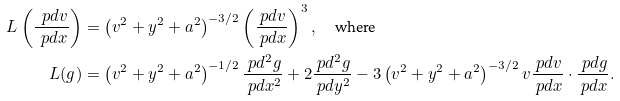<formula> <loc_0><loc_0><loc_500><loc_500>L \left ( \frac { \ p d v } { \ p d x } \right ) & = \left ( v ^ { 2 } + y ^ { 2 } + a ^ { 2 } \right ) ^ { - 3 / 2 } \left ( \frac { \ p d v } { \ p d x } \right ) ^ { 3 } , \quad \text {where} \\ L ( g ) & = \left ( v ^ { 2 } + y ^ { 2 } + a ^ { 2 } \right ) ^ { - 1 / 2 } \frac { \ p d ^ { 2 } g } { \ p d x ^ { 2 } } + 2 \frac { \ p d ^ { 2 } g } { \ p d y ^ { 2 } } - 3 \left ( v ^ { 2 } + y ^ { 2 } + a ^ { 2 } \right ) ^ { - 3 / 2 } v \frac { \ p d v } { \ p d x } \cdot \frac { \ p d g } { \ p d x } .</formula> 